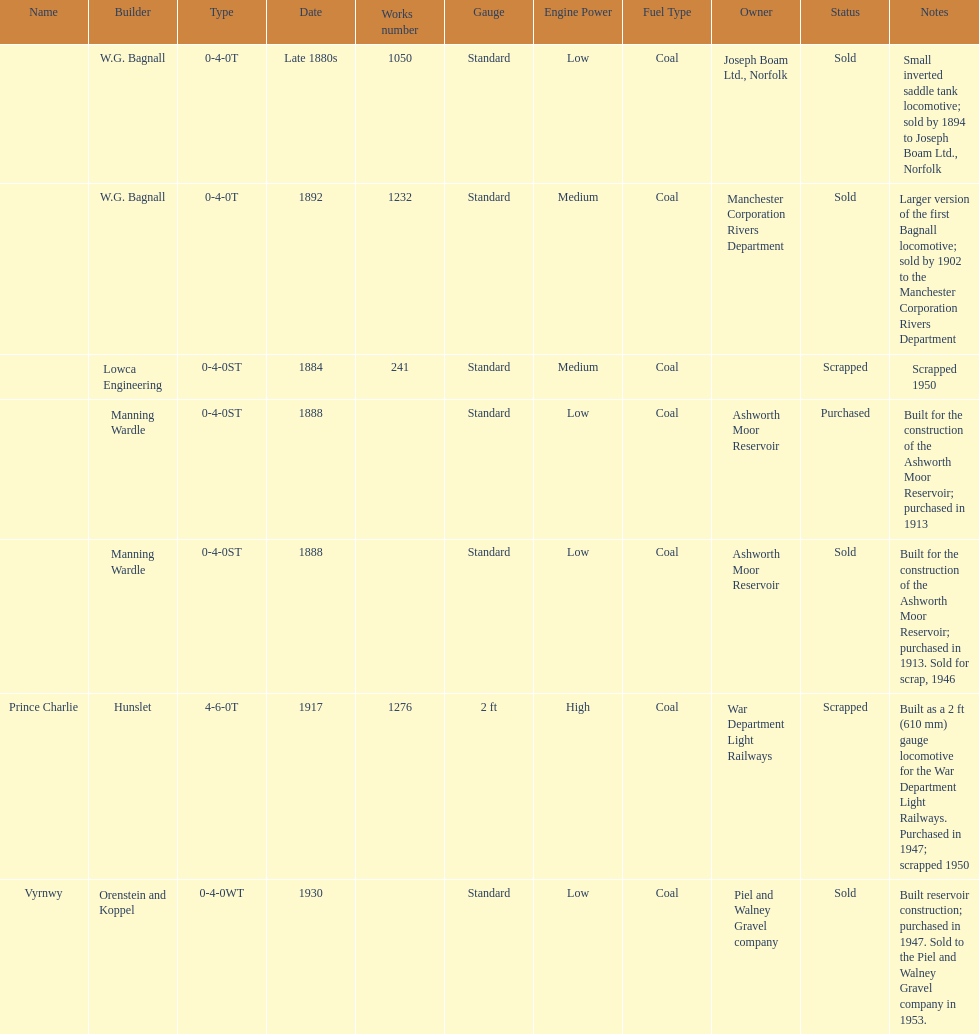Which locomotive builder built a locomotive after 1888 and built the locomotive as a 2ft gauge locomotive? Hunslet. 